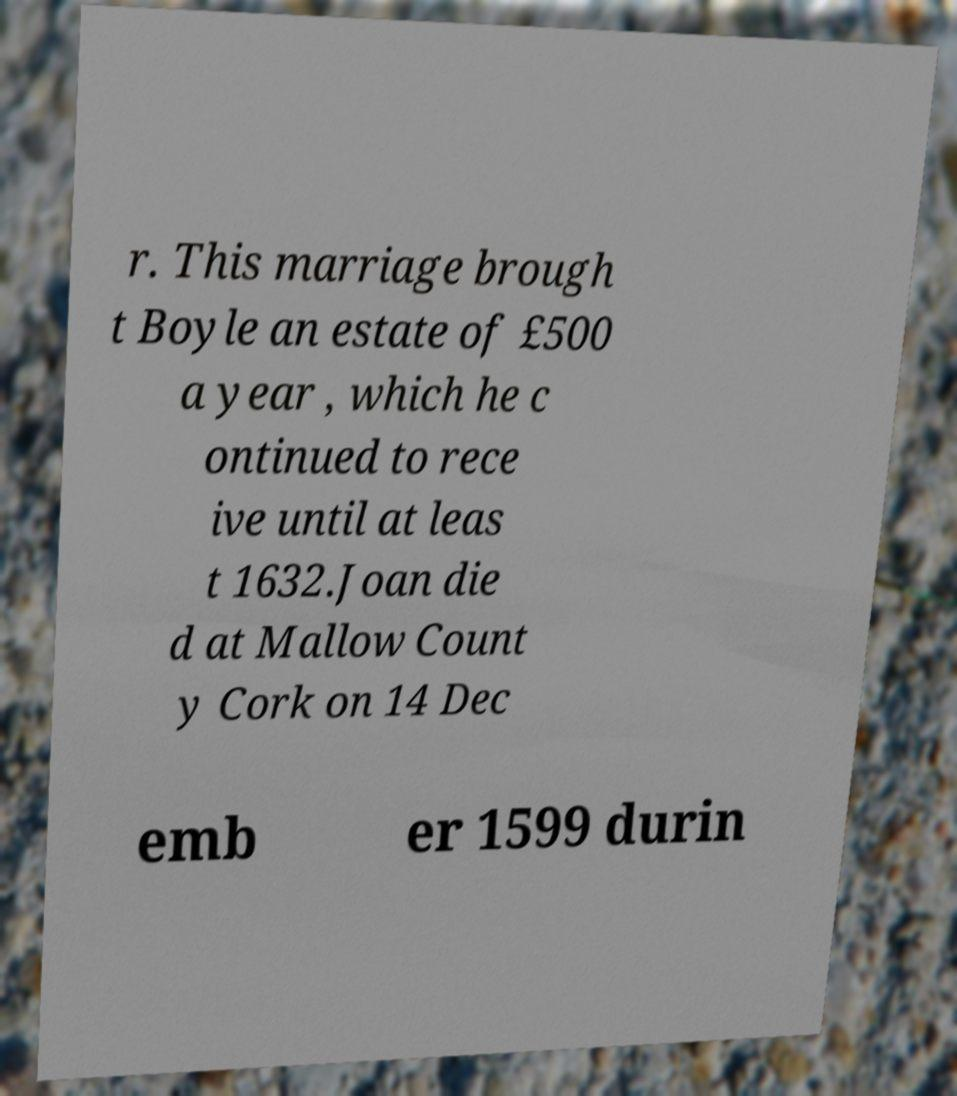Can you accurately transcribe the text from the provided image for me? r. This marriage brough t Boyle an estate of £500 a year , which he c ontinued to rece ive until at leas t 1632.Joan die d at Mallow Count y Cork on 14 Dec emb er 1599 durin 